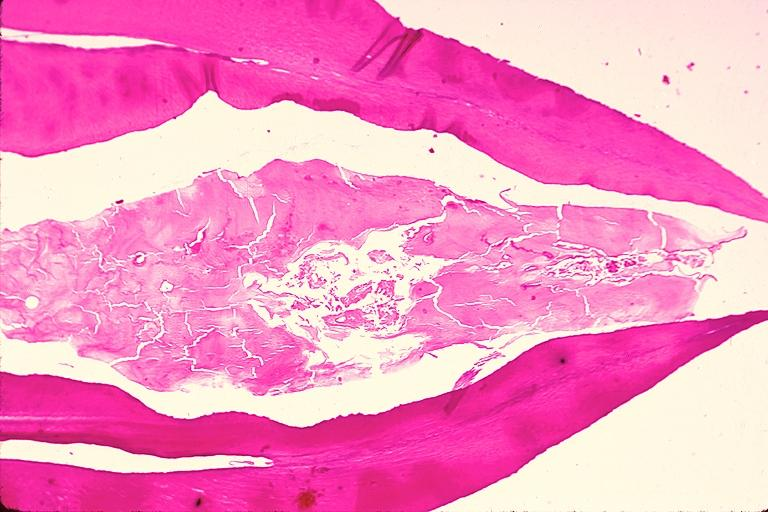does this image show dens invaginatus?
Answer the question using a single word or phrase. Yes 